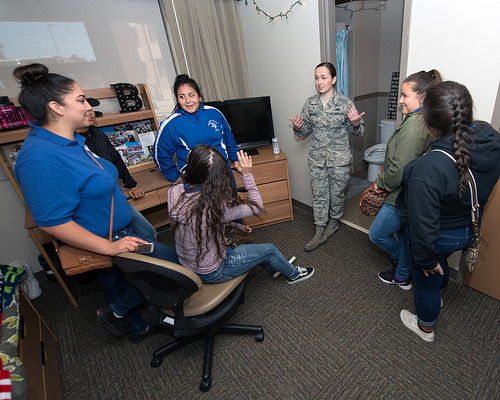<image>
Is there a computer next to the window? Yes. The computer is positioned adjacent to the window, located nearby in the same general area. 